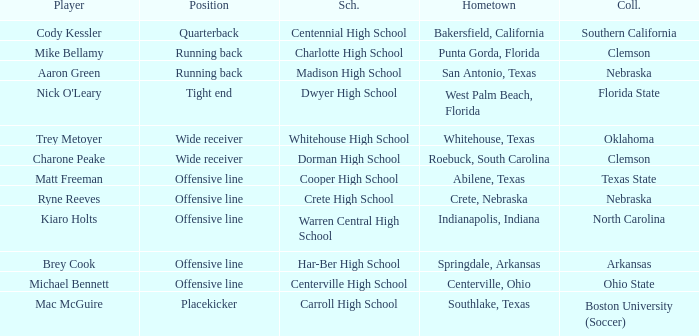What was the position of the player that went to warren central high school? Offensive line. 